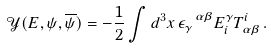<formula> <loc_0><loc_0><loc_500><loc_500>\mathcal { Y } ( E , \psi , \overline { \psi } ) = - \frac { 1 } { 2 } \int d ^ { 3 } x \, \epsilon _ { \gamma } ^ { \ \alpha \beta } E ^ { \gamma } _ { i } T _ { \alpha \beta } ^ { i } \, .</formula> 